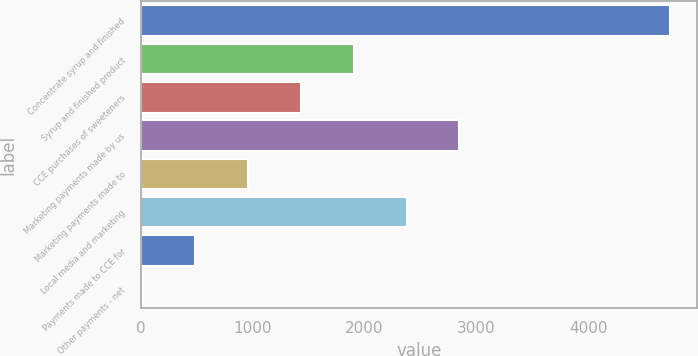<chart> <loc_0><loc_0><loc_500><loc_500><bar_chart><fcel>Concentrate syrup and finished<fcel>Syrup and finished product<fcel>CCE purchases of sweeteners<fcel>Marketing payments made by us<fcel>Marketing payments made to<fcel>Local media and marketing<fcel>Payments made to CCE for<fcel>Other payments - net<nl><fcel>4737<fcel>1906.2<fcel>1434.4<fcel>2849.8<fcel>962.6<fcel>2378<fcel>490.8<fcel>19<nl></chart> 